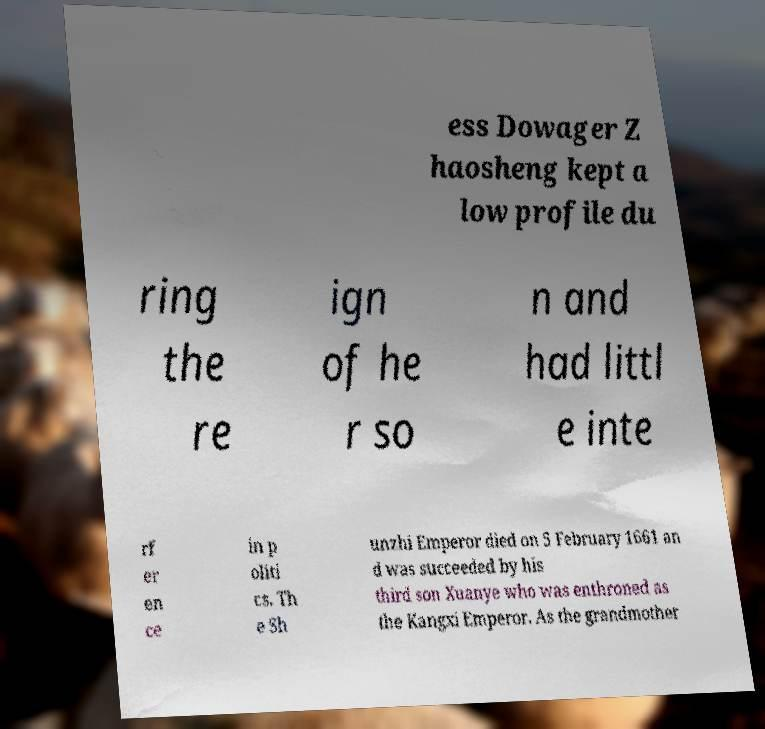Could you assist in decoding the text presented in this image and type it out clearly? ess Dowager Z haosheng kept a low profile du ring the re ign of he r so n and had littl e inte rf er en ce in p oliti cs. Th e Sh unzhi Emperor died on 5 February 1661 an d was succeeded by his third son Xuanye who was enthroned as the Kangxi Emperor. As the grandmother 